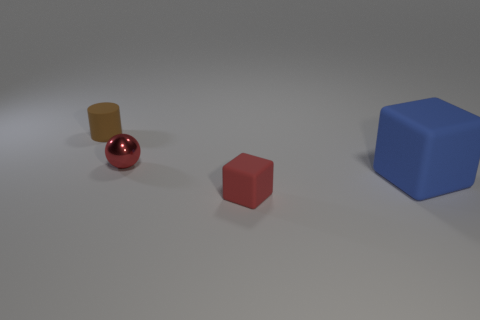Can you describe the lighting and shadows in the scene? The lighting in the scene is diffused, creating a gentle gradation of shadows on the surface below each object. The most prominent shadow is cast by the blue cube, indicating a light source situated towards the right of the image. The shadows indicate that all objects are resting on the same flat surface, contributing to spatial coherence in the composition. 